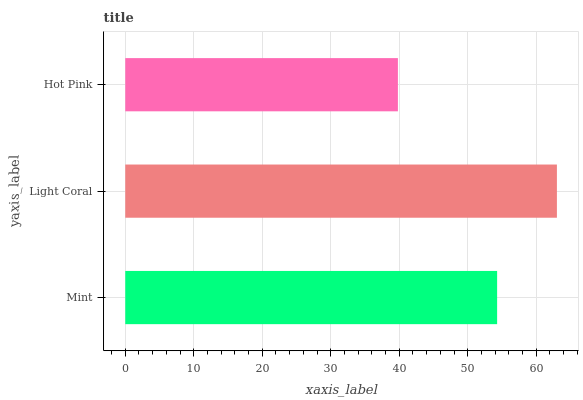Is Hot Pink the minimum?
Answer yes or no. Yes. Is Light Coral the maximum?
Answer yes or no. Yes. Is Light Coral the minimum?
Answer yes or no. No. Is Hot Pink the maximum?
Answer yes or no. No. Is Light Coral greater than Hot Pink?
Answer yes or no. Yes. Is Hot Pink less than Light Coral?
Answer yes or no. Yes. Is Hot Pink greater than Light Coral?
Answer yes or no. No. Is Light Coral less than Hot Pink?
Answer yes or no. No. Is Mint the high median?
Answer yes or no. Yes. Is Mint the low median?
Answer yes or no. Yes. Is Light Coral the high median?
Answer yes or no. No. Is Light Coral the low median?
Answer yes or no. No. 